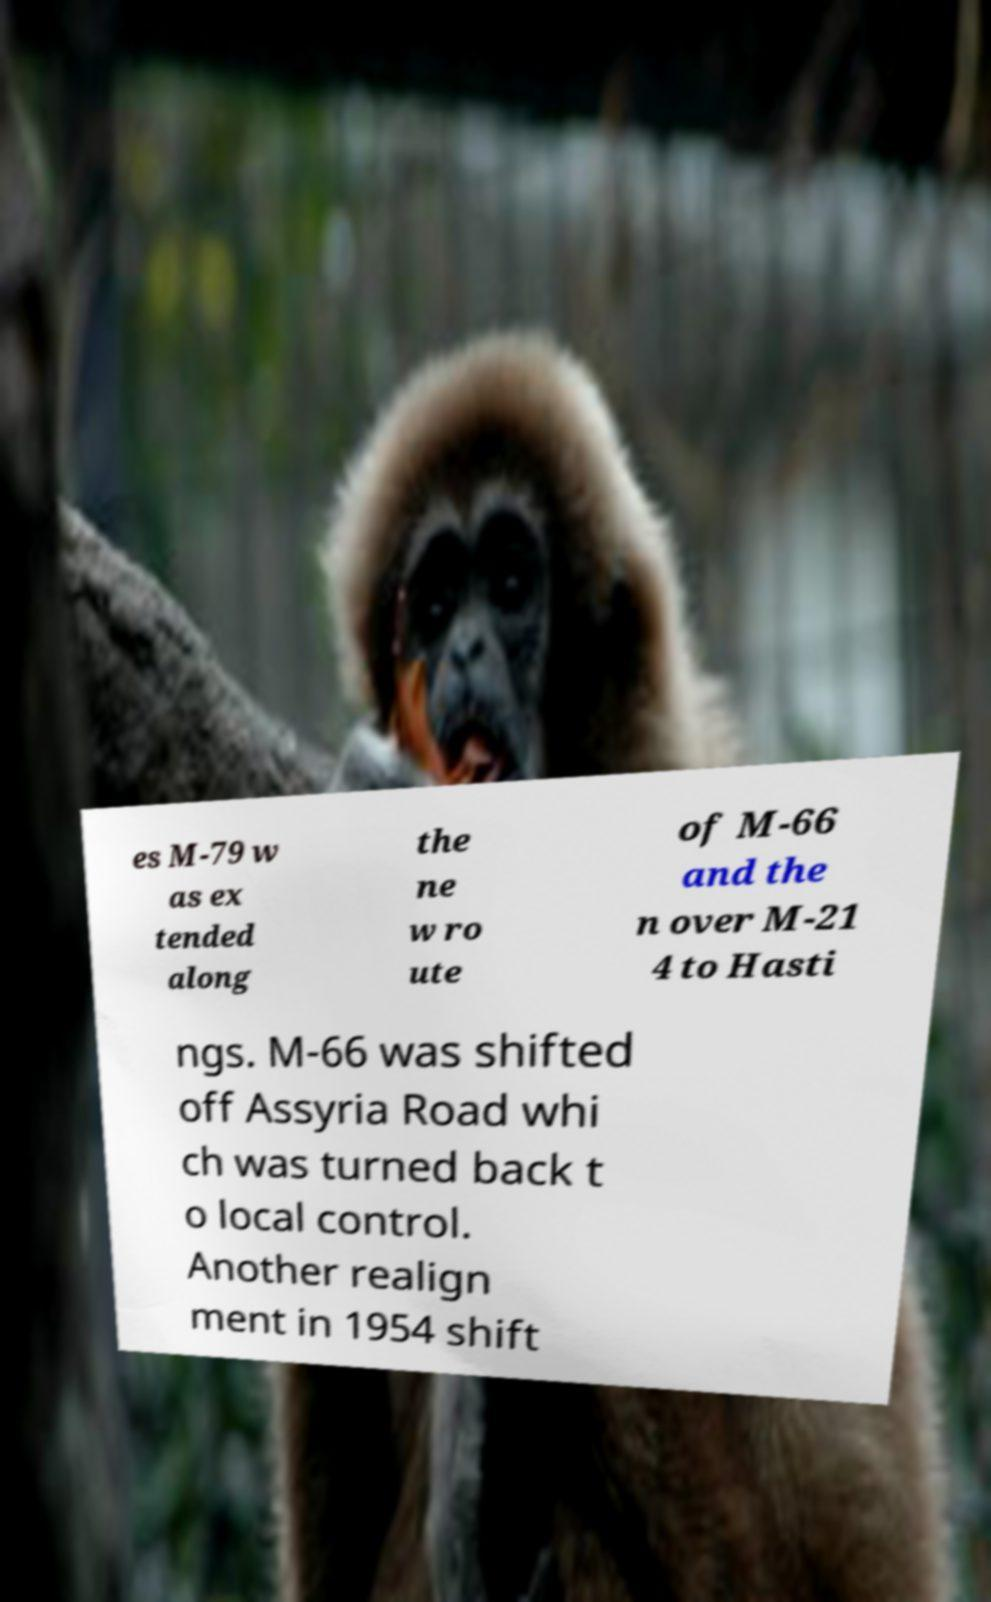Could you assist in decoding the text presented in this image and type it out clearly? es M-79 w as ex tended along the ne w ro ute of M-66 and the n over M-21 4 to Hasti ngs. M-66 was shifted off Assyria Road whi ch was turned back t o local control. Another realign ment in 1954 shift 